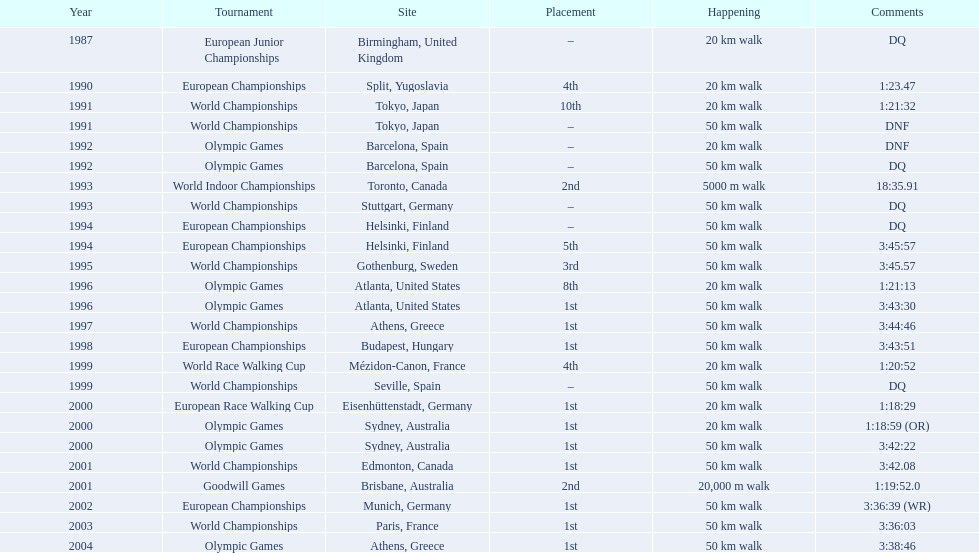What are the notes DQ, 1:23.47, 1:21:32, DNF, DNF, DQ, 18:35.91, DQ, DQ, 3:45:57, 3:45.57, 1:21:13, 3:43:30, 3:44:46, 3:43:51, 1:20:52, DQ, 1:18:29, 1:18:59 (OR), 3:42:22, 3:42.08, 1:19:52.0, 3:36:39 (WR), 3:36:03, 3:38:46. What time does the notes for 2004 show 3:38:46. Could you help me parse every detail presented in this table? {'header': ['Year', 'Tournament', 'Site', 'Placement', 'Happening', 'Comments'], 'rows': [['1987', 'European Junior Championships', 'Birmingham, United Kingdom', '–', '20\xa0km walk', 'DQ'], ['1990', 'European Championships', 'Split, Yugoslavia', '4th', '20\xa0km walk', '1:23.47'], ['1991', 'World Championships', 'Tokyo, Japan', '10th', '20\xa0km walk', '1:21:32'], ['1991', 'World Championships', 'Tokyo, Japan', '–', '50\xa0km walk', 'DNF'], ['1992', 'Olympic Games', 'Barcelona, Spain', '–', '20\xa0km walk', 'DNF'], ['1992', 'Olympic Games', 'Barcelona, Spain', '–', '50\xa0km walk', 'DQ'], ['1993', 'World Indoor Championships', 'Toronto, Canada', '2nd', '5000 m walk', '18:35.91'], ['1993', 'World Championships', 'Stuttgart, Germany', '–', '50\xa0km walk', 'DQ'], ['1994', 'European Championships', 'Helsinki, Finland', '–', '50\xa0km walk', 'DQ'], ['1994', 'European Championships', 'Helsinki, Finland', '5th', '50\xa0km walk', '3:45:57'], ['1995', 'World Championships', 'Gothenburg, Sweden', '3rd', '50\xa0km walk', '3:45.57'], ['1996', 'Olympic Games', 'Atlanta, United States', '8th', '20\xa0km walk', '1:21:13'], ['1996', 'Olympic Games', 'Atlanta, United States', '1st', '50\xa0km walk', '3:43:30'], ['1997', 'World Championships', 'Athens, Greece', '1st', '50\xa0km walk', '3:44:46'], ['1998', 'European Championships', 'Budapest, Hungary', '1st', '50\xa0km walk', '3:43:51'], ['1999', 'World Race Walking Cup', 'Mézidon-Canon, France', '4th', '20\xa0km walk', '1:20:52'], ['1999', 'World Championships', 'Seville, Spain', '–', '50\xa0km walk', 'DQ'], ['2000', 'European Race Walking Cup', 'Eisenhüttenstadt, Germany', '1st', '20\xa0km walk', '1:18:29'], ['2000', 'Olympic Games', 'Sydney, Australia', '1st', '20\xa0km walk', '1:18:59 (OR)'], ['2000', 'Olympic Games', 'Sydney, Australia', '1st', '50\xa0km walk', '3:42:22'], ['2001', 'World Championships', 'Edmonton, Canada', '1st', '50\xa0km walk', '3:42.08'], ['2001', 'Goodwill Games', 'Brisbane, Australia', '2nd', '20,000 m walk', '1:19:52.0'], ['2002', 'European Championships', 'Munich, Germany', '1st', '50\xa0km walk', '3:36:39 (WR)'], ['2003', 'World Championships', 'Paris, France', '1st', '50\xa0km walk', '3:36:03'], ['2004', 'Olympic Games', 'Athens, Greece', '1st', '50\xa0km walk', '3:38:46']]} 